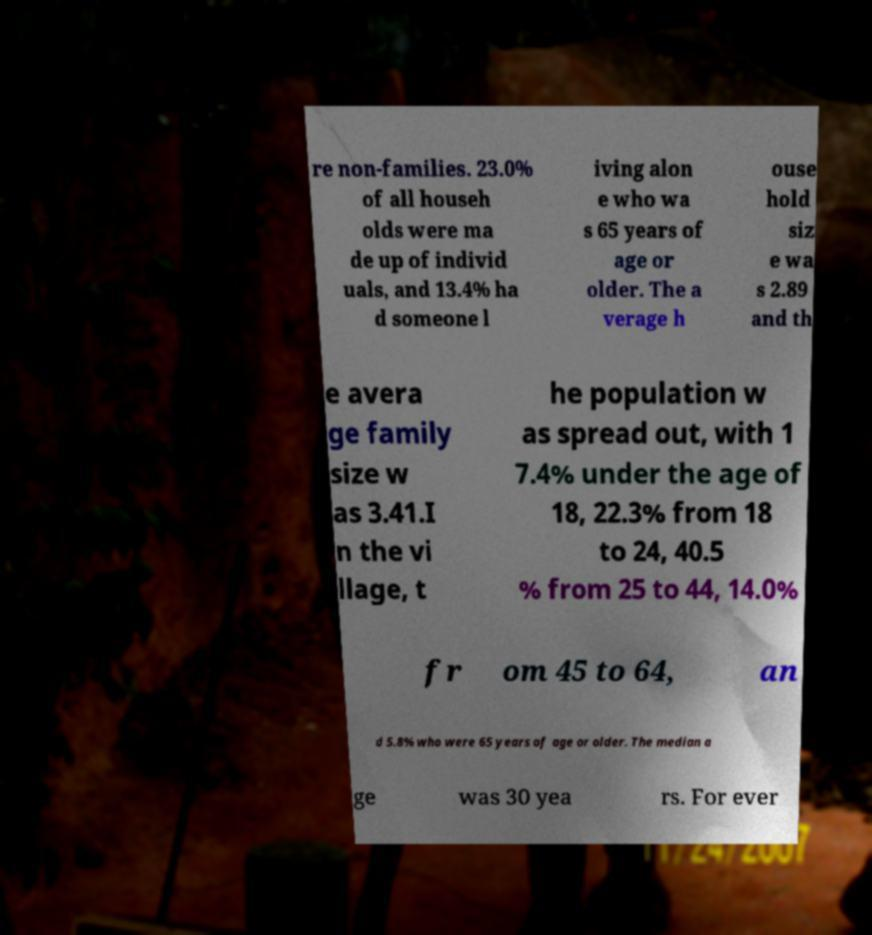Could you assist in decoding the text presented in this image and type it out clearly? re non-families. 23.0% of all househ olds were ma de up of individ uals, and 13.4% ha d someone l iving alon e who wa s 65 years of age or older. The a verage h ouse hold siz e wa s 2.89 and th e avera ge family size w as 3.41.I n the vi llage, t he population w as spread out, with 1 7.4% under the age of 18, 22.3% from 18 to 24, 40.5 % from 25 to 44, 14.0% fr om 45 to 64, an d 5.8% who were 65 years of age or older. The median a ge was 30 yea rs. For ever 